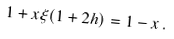<formula> <loc_0><loc_0><loc_500><loc_500>1 + x \xi ( 1 + 2 h ) = 1 - x \, .</formula> 